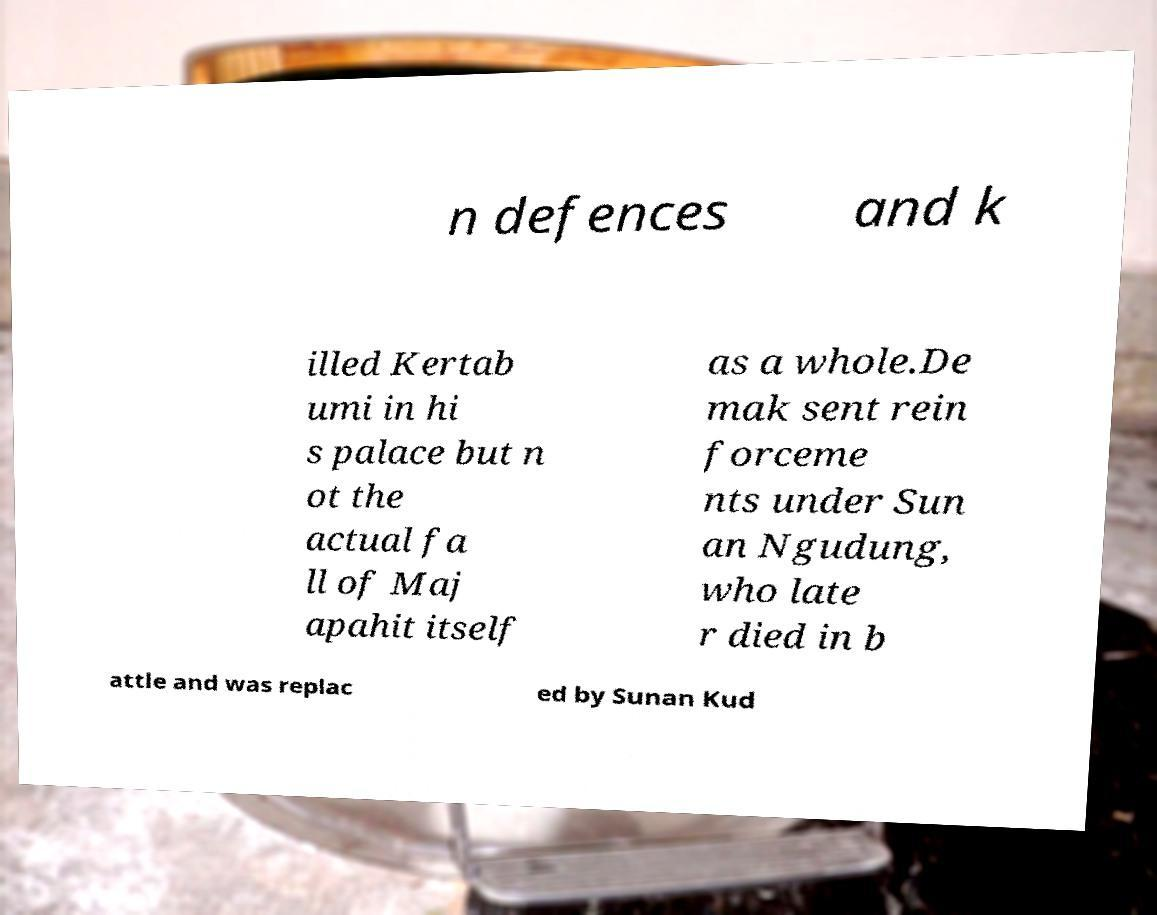Can you accurately transcribe the text from the provided image for me? n defences and k illed Kertab umi in hi s palace but n ot the actual fa ll of Maj apahit itself as a whole.De mak sent rein forceme nts under Sun an Ngudung, who late r died in b attle and was replac ed by Sunan Kud 